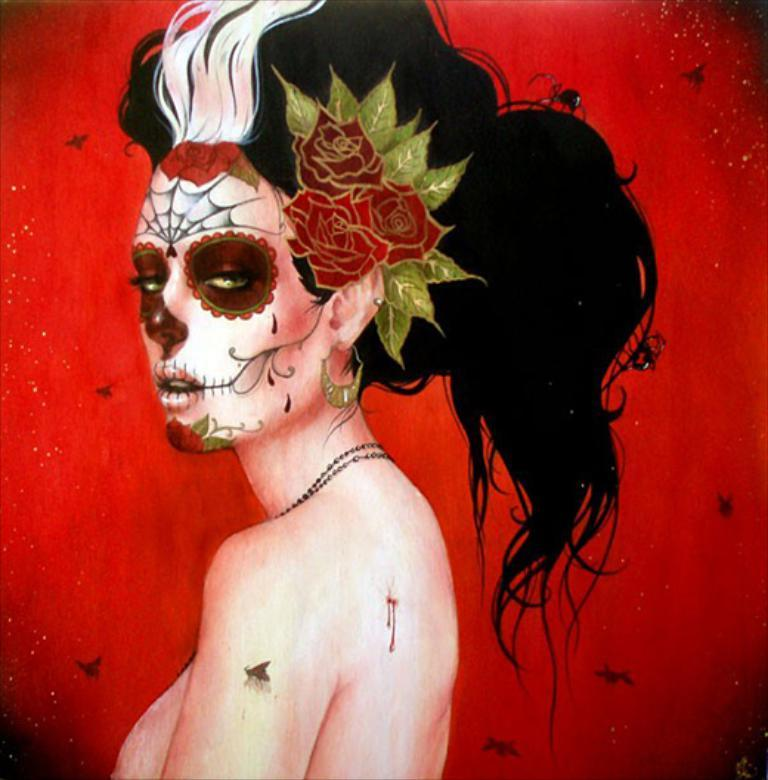What is featured in the image? There is a painting in the image. What is the subject of the painting? The painting depicts a woman. Where is the painting located? The painting is on a wall. What type of tent is set up in the image? There is no tent present in the image; it features a painting of a woman on a wall. What rule is being enforced in the image? There is no rule being enforced in the image; it only shows a painting of a woman on a wall. 